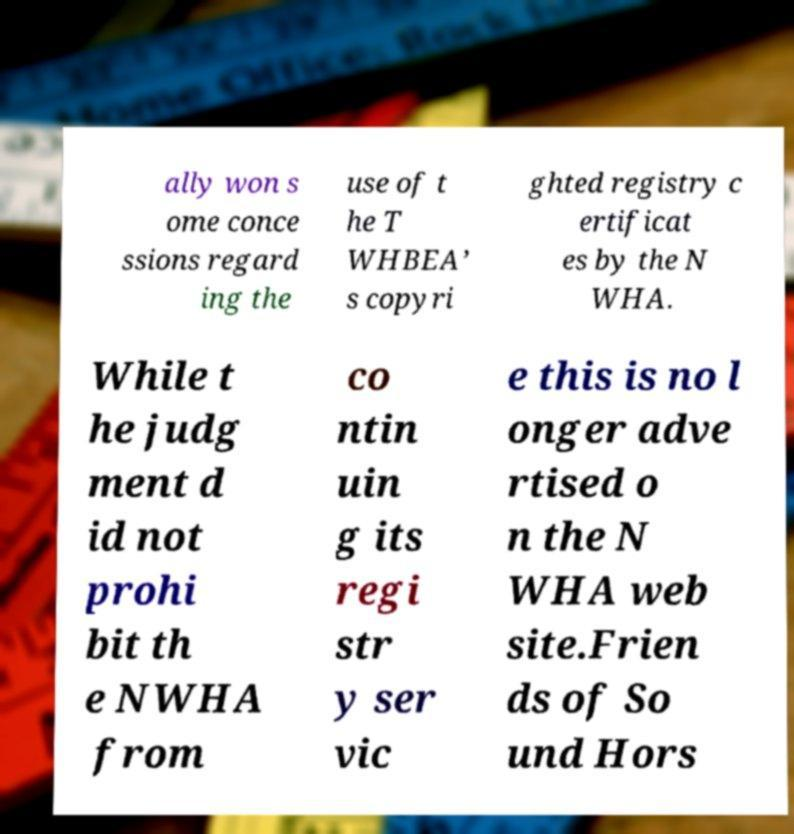I need the written content from this picture converted into text. Can you do that? ally won s ome conce ssions regard ing the use of t he T WHBEA’ s copyri ghted registry c ertificat es by the N WHA. While t he judg ment d id not prohi bit th e NWHA from co ntin uin g its regi str y ser vic e this is no l onger adve rtised o n the N WHA web site.Frien ds of So und Hors 